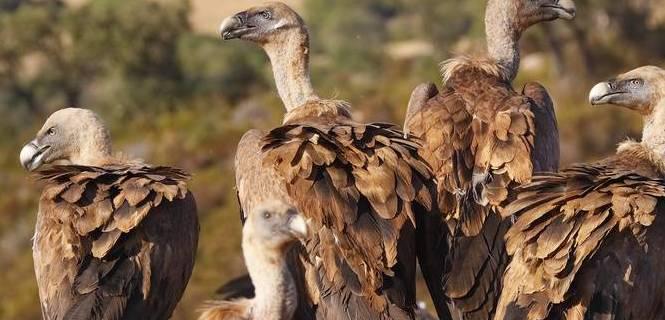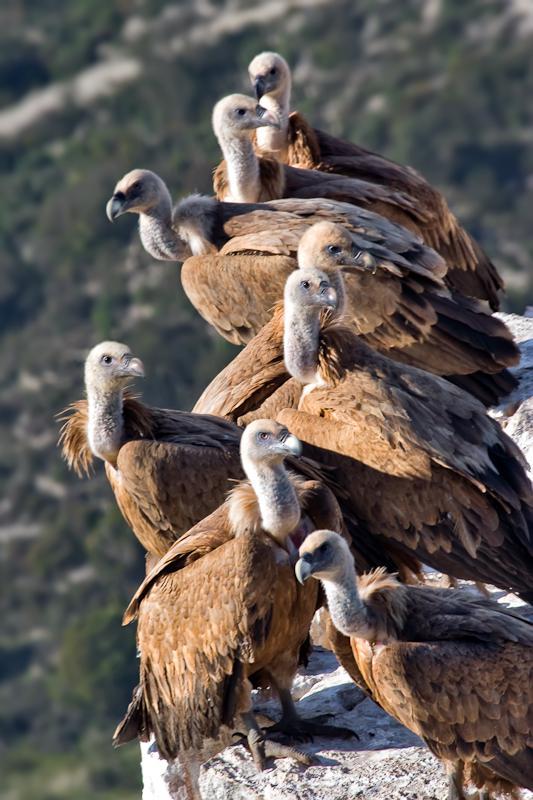The first image is the image on the left, the second image is the image on the right. Evaluate the accuracy of this statement regarding the images: "In at least one image there are four vultures.". Is it true? Answer yes or no. Yes. The first image is the image on the left, the second image is the image on the right. For the images displayed, is the sentence "One of the images shows four vultures, while the other shows many more, and none of them are currently eating." factually correct? Answer yes or no. Yes. 